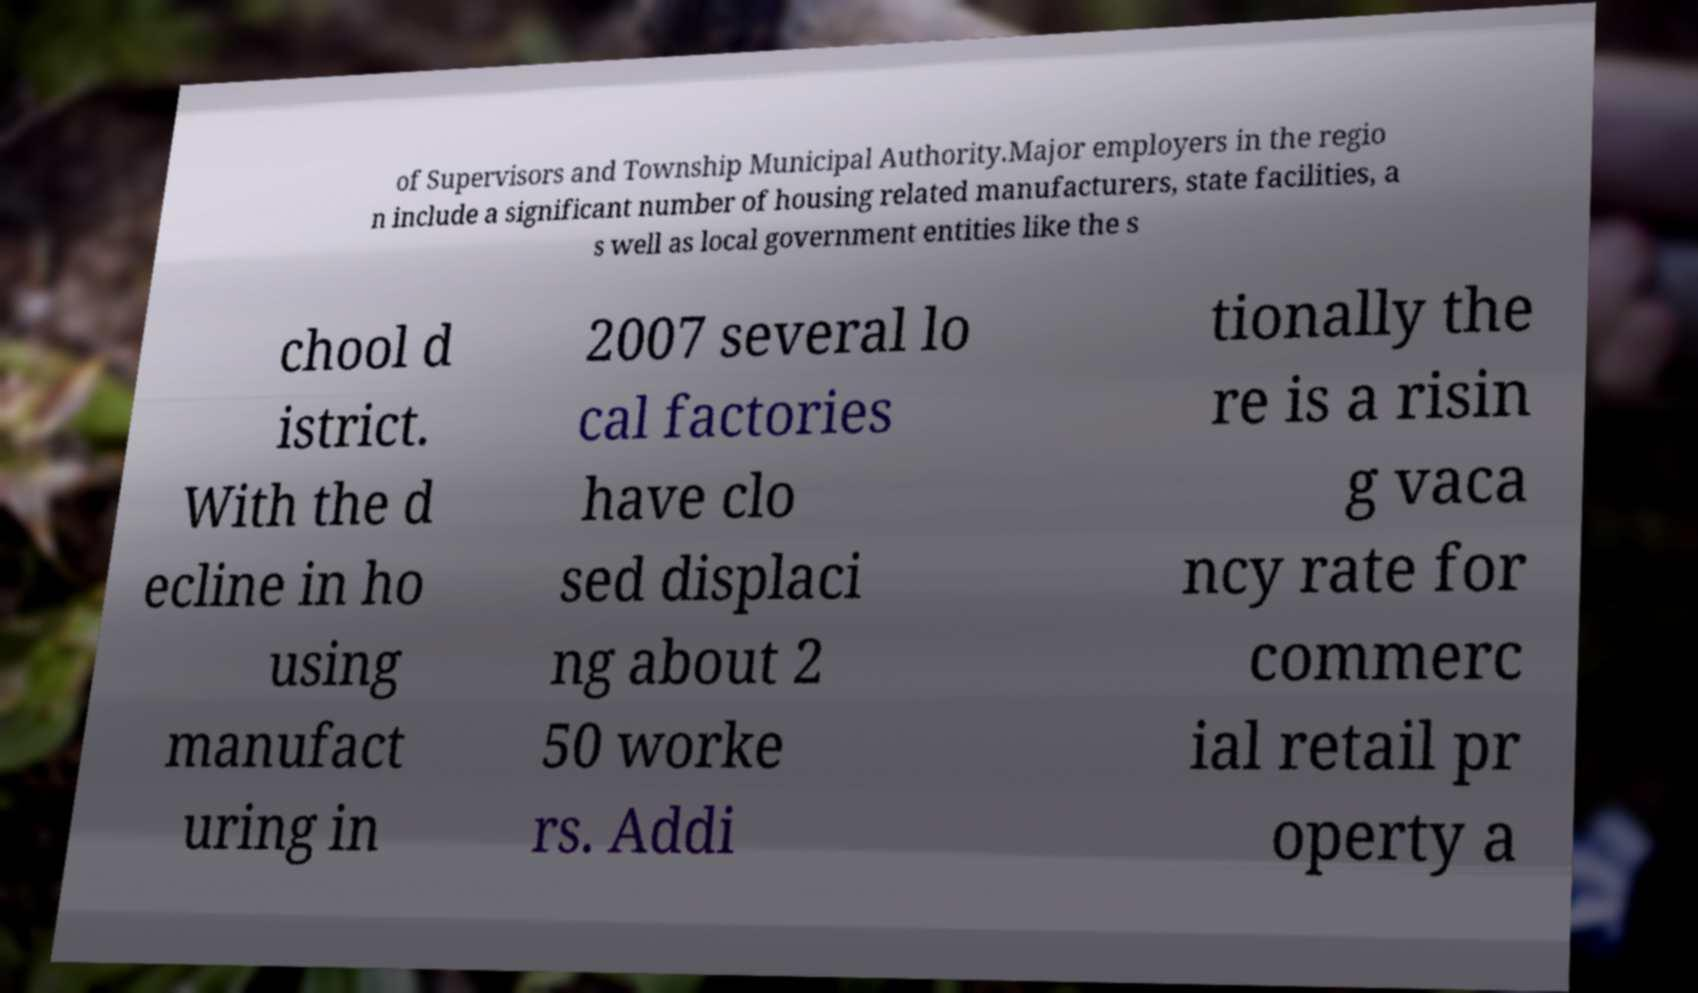For documentation purposes, I need the text within this image transcribed. Could you provide that? of Supervisors and Township Municipal Authority.Major employers in the regio n include a significant number of housing related manufacturers, state facilities, a s well as local government entities like the s chool d istrict. With the d ecline in ho using manufact uring in 2007 several lo cal factories have clo sed displaci ng about 2 50 worke rs. Addi tionally the re is a risin g vaca ncy rate for commerc ial retail pr operty a 